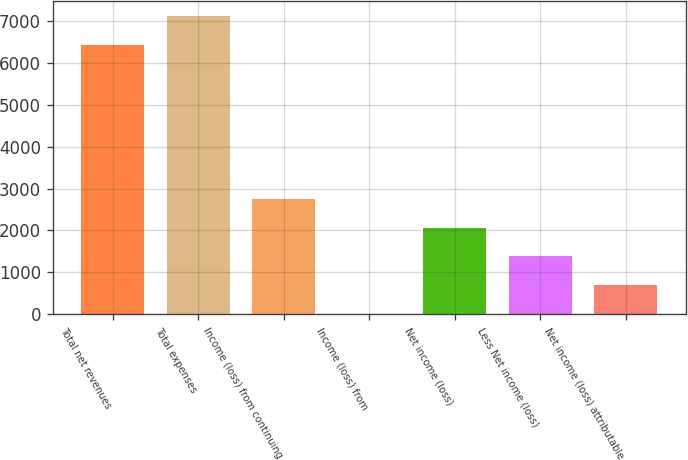Convert chart to OTSL. <chart><loc_0><loc_0><loc_500><loc_500><bar_chart><fcel>Total net revenues<fcel>Total expenses<fcel>Income (loss) from continuing<fcel>Income (loss) from<fcel>Net income (loss)<fcel>Less Net income (loss)<fcel>Net income (loss) attributable<nl><fcel>6433<fcel>7119.7<fcel>2756.8<fcel>10<fcel>2070.1<fcel>1383.4<fcel>696.7<nl></chart> 